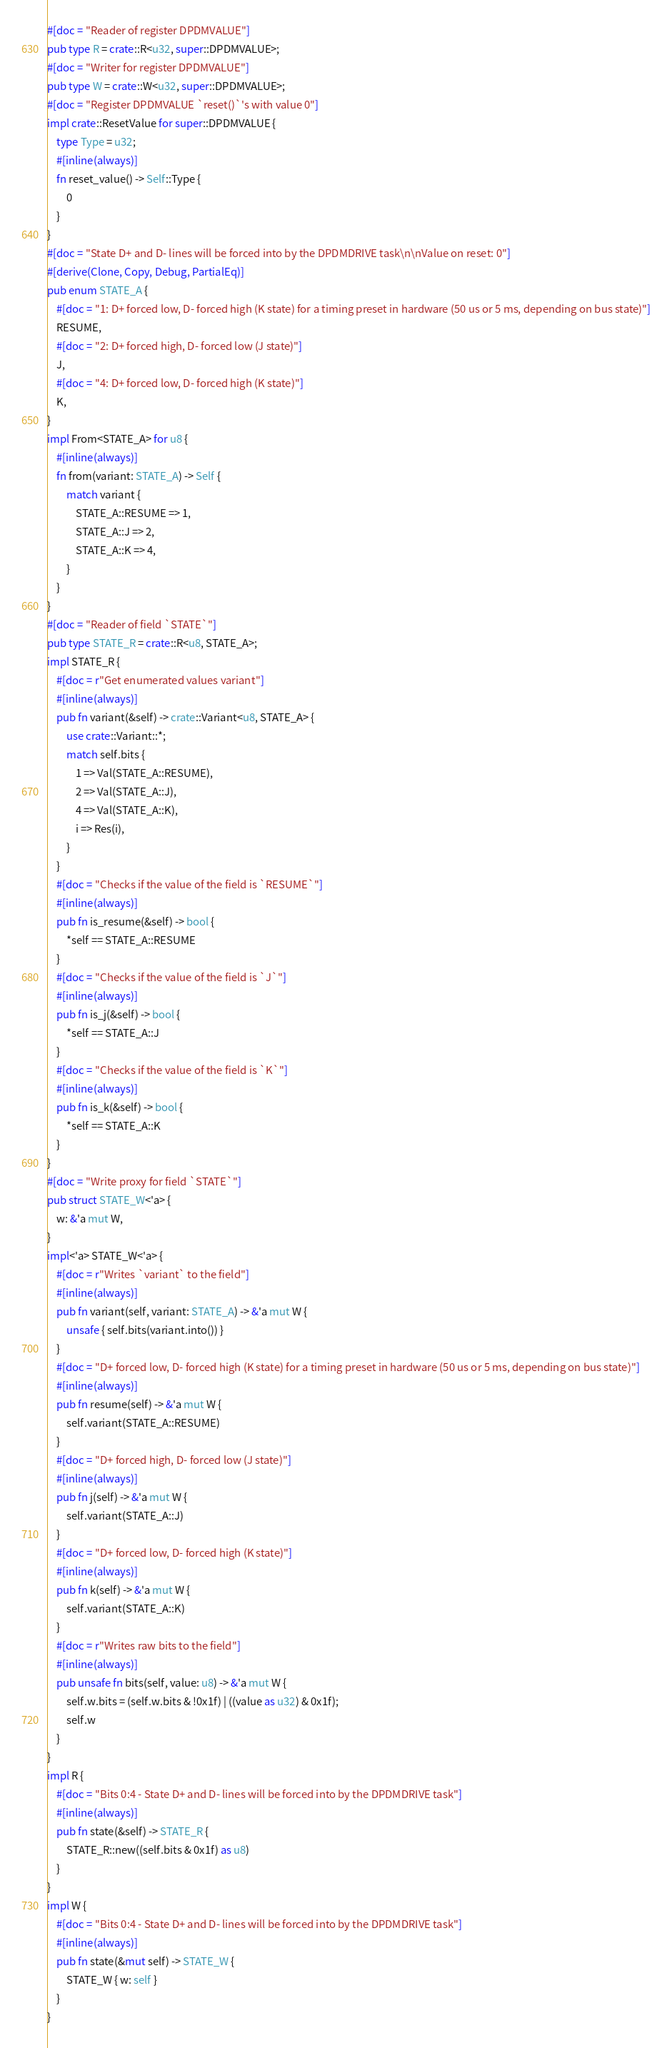<code> <loc_0><loc_0><loc_500><loc_500><_Rust_>#[doc = "Reader of register DPDMVALUE"]
pub type R = crate::R<u32, super::DPDMVALUE>;
#[doc = "Writer for register DPDMVALUE"]
pub type W = crate::W<u32, super::DPDMVALUE>;
#[doc = "Register DPDMVALUE `reset()`'s with value 0"]
impl crate::ResetValue for super::DPDMVALUE {
    type Type = u32;
    #[inline(always)]
    fn reset_value() -> Self::Type {
        0
    }
}
#[doc = "State D+ and D- lines will be forced into by the DPDMDRIVE task\n\nValue on reset: 0"]
#[derive(Clone, Copy, Debug, PartialEq)]
pub enum STATE_A {
    #[doc = "1: D+ forced low, D- forced high (K state) for a timing preset in hardware (50 us or 5 ms, depending on bus state)"]
    RESUME,
    #[doc = "2: D+ forced high, D- forced low (J state)"]
    J,
    #[doc = "4: D+ forced low, D- forced high (K state)"]
    K,
}
impl From<STATE_A> for u8 {
    #[inline(always)]
    fn from(variant: STATE_A) -> Self {
        match variant {
            STATE_A::RESUME => 1,
            STATE_A::J => 2,
            STATE_A::K => 4,
        }
    }
}
#[doc = "Reader of field `STATE`"]
pub type STATE_R = crate::R<u8, STATE_A>;
impl STATE_R {
    #[doc = r"Get enumerated values variant"]
    #[inline(always)]
    pub fn variant(&self) -> crate::Variant<u8, STATE_A> {
        use crate::Variant::*;
        match self.bits {
            1 => Val(STATE_A::RESUME),
            2 => Val(STATE_A::J),
            4 => Val(STATE_A::K),
            i => Res(i),
        }
    }
    #[doc = "Checks if the value of the field is `RESUME`"]
    #[inline(always)]
    pub fn is_resume(&self) -> bool {
        *self == STATE_A::RESUME
    }
    #[doc = "Checks if the value of the field is `J`"]
    #[inline(always)]
    pub fn is_j(&self) -> bool {
        *self == STATE_A::J
    }
    #[doc = "Checks if the value of the field is `K`"]
    #[inline(always)]
    pub fn is_k(&self) -> bool {
        *self == STATE_A::K
    }
}
#[doc = "Write proxy for field `STATE`"]
pub struct STATE_W<'a> {
    w: &'a mut W,
}
impl<'a> STATE_W<'a> {
    #[doc = r"Writes `variant` to the field"]
    #[inline(always)]
    pub fn variant(self, variant: STATE_A) -> &'a mut W {
        unsafe { self.bits(variant.into()) }
    }
    #[doc = "D+ forced low, D- forced high (K state) for a timing preset in hardware (50 us or 5 ms, depending on bus state)"]
    #[inline(always)]
    pub fn resume(self) -> &'a mut W {
        self.variant(STATE_A::RESUME)
    }
    #[doc = "D+ forced high, D- forced low (J state)"]
    #[inline(always)]
    pub fn j(self) -> &'a mut W {
        self.variant(STATE_A::J)
    }
    #[doc = "D+ forced low, D- forced high (K state)"]
    #[inline(always)]
    pub fn k(self) -> &'a mut W {
        self.variant(STATE_A::K)
    }
    #[doc = r"Writes raw bits to the field"]
    #[inline(always)]
    pub unsafe fn bits(self, value: u8) -> &'a mut W {
        self.w.bits = (self.w.bits & !0x1f) | ((value as u32) & 0x1f);
        self.w
    }
}
impl R {
    #[doc = "Bits 0:4 - State D+ and D- lines will be forced into by the DPDMDRIVE task"]
    #[inline(always)]
    pub fn state(&self) -> STATE_R {
        STATE_R::new((self.bits & 0x1f) as u8)
    }
}
impl W {
    #[doc = "Bits 0:4 - State D+ and D- lines will be forced into by the DPDMDRIVE task"]
    #[inline(always)]
    pub fn state(&mut self) -> STATE_W {
        STATE_W { w: self }
    }
}
</code> 